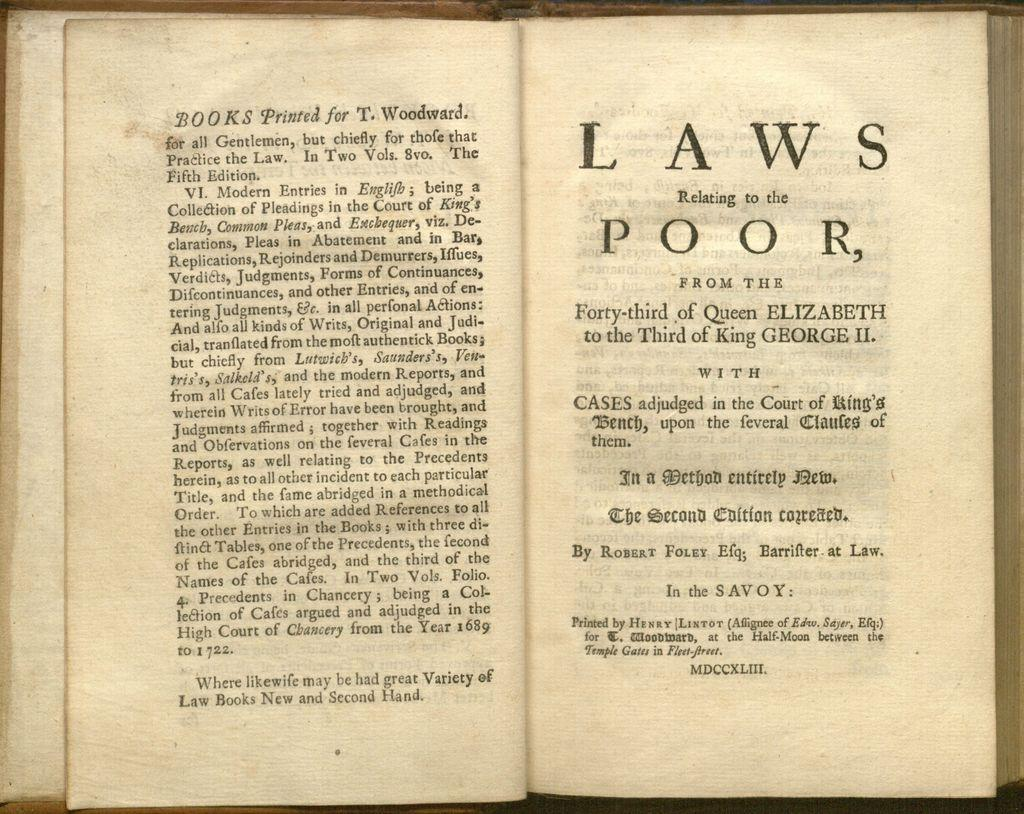<image>
Summarize the visual content of the image. Book that is open about Laws from Queen Elizabeth 